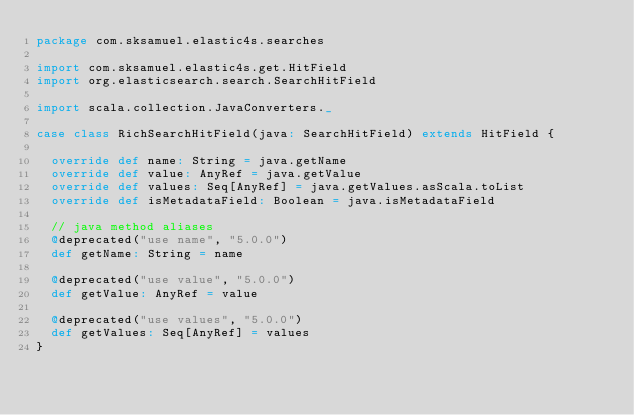Convert code to text. <code><loc_0><loc_0><loc_500><loc_500><_Scala_>package com.sksamuel.elastic4s.searches

import com.sksamuel.elastic4s.get.HitField
import org.elasticsearch.search.SearchHitField

import scala.collection.JavaConverters._

case class RichSearchHitField(java: SearchHitField) extends HitField {

  override def name: String = java.getName
  override def value: AnyRef = java.getValue
  override def values: Seq[AnyRef] = java.getValues.asScala.toList
  override def isMetadataField: Boolean = java.isMetadataField

  // java method aliases
  @deprecated("use name", "5.0.0")
  def getName: String = name

  @deprecated("use value", "5.0.0")
  def getValue: AnyRef = value

  @deprecated("use values", "5.0.0")
  def getValues: Seq[AnyRef] = values
}
</code> 